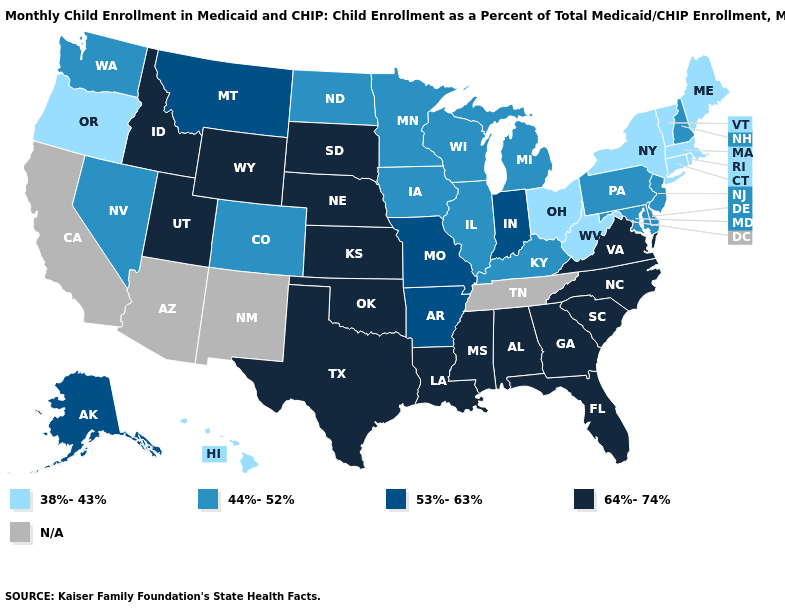Among the states that border New Mexico , does Colorado have the lowest value?
Short answer required. Yes. What is the value of North Dakota?
Write a very short answer. 44%-52%. Does Indiana have the lowest value in the MidWest?
Concise answer only. No. Is the legend a continuous bar?
Quick response, please. No. Among the states that border Illinois , which have the lowest value?
Write a very short answer. Iowa, Kentucky, Wisconsin. Name the states that have a value in the range 38%-43%?
Be succinct. Connecticut, Hawaii, Maine, Massachusetts, New York, Ohio, Oregon, Rhode Island, Vermont, West Virginia. What is the value of Ohio?
Short answer required. 38%-43%. Which states have the highest value in the USA?
Write a very short answer. Alabama, Florida, Georgia, Idaho, Kansas, Louisiana, Mississippi, Nebraska, North Carolina, Oklahoma, South Carolina, South Dakota, Texas, Utah, Virginia, Wyoming. What is the value of Connecticut?
Answer briefly. 38%-43%. Name the states that have a value in the range 53%-63%?
Concise answer only. Alaska, Arkansas, Indiana, Missouri, Montana. Name the states that have a value in the range 38%-43%?
Write a very short answer. Connecticut, Hawaii, Maine, Massachusetts, New York, Ohio, Oregon, Rhode Island, Vermont, West Virginia. What is the value of Tennessee?
Write a very short answer. N/A. What is the value of Kentucky?
Short answer required. 44%-52%. 